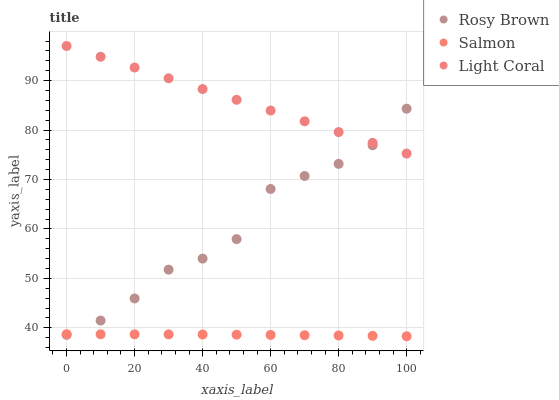Does Salmon have the minimum area under the curve?
Answer yes or no. Yes. Does Light Coral have the maximum area under the curve?
Answer yes or no. Yes. Does Rosy Brown have the minimum area under the curve?
Answer yes or no. No. Does Rosy Brown have the maximum area under the curve?
Answer yes or no. No. Is Light Coral the smoothest?
Answer yes or no. Yes. Is Rosy Brown the roughest?
Answer yes or no. Yes. Is Salmon the smoothest?
Answer yes or no. No. Is Salmon the roughest?
Answer yes or no. No. Does Salmon have the lowest value?
Answer yes or no. Yes. Does Rosy Brown have the lowest value?
Answer yes or no. No. Does Light Coral have the highest value?
Answer yes or no. Yes. Does Rosy Brown have the highest value?
Answer yes or no. No. Is Salmon less than Light Coral?
Answer yes or no. Yes. Is Light Coral greater than Salmon?
Answer yes or no. Yes. Does Rosy Brown intersect Salmon?
Answer yes or no. Yes. Is Rosy Brown less than Salmon?
Answer yes or no. No. Is Rosy Brown greater than Salmon?
Answer yes or no. No. Does Salmon intersect Light Coral?
Answer yes or no. No. 